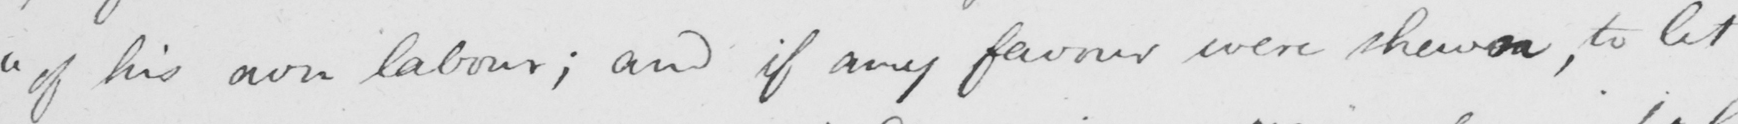Please transcribe the handwritten text in this image. " of his own labour ; and if any favour were shewn , to let 